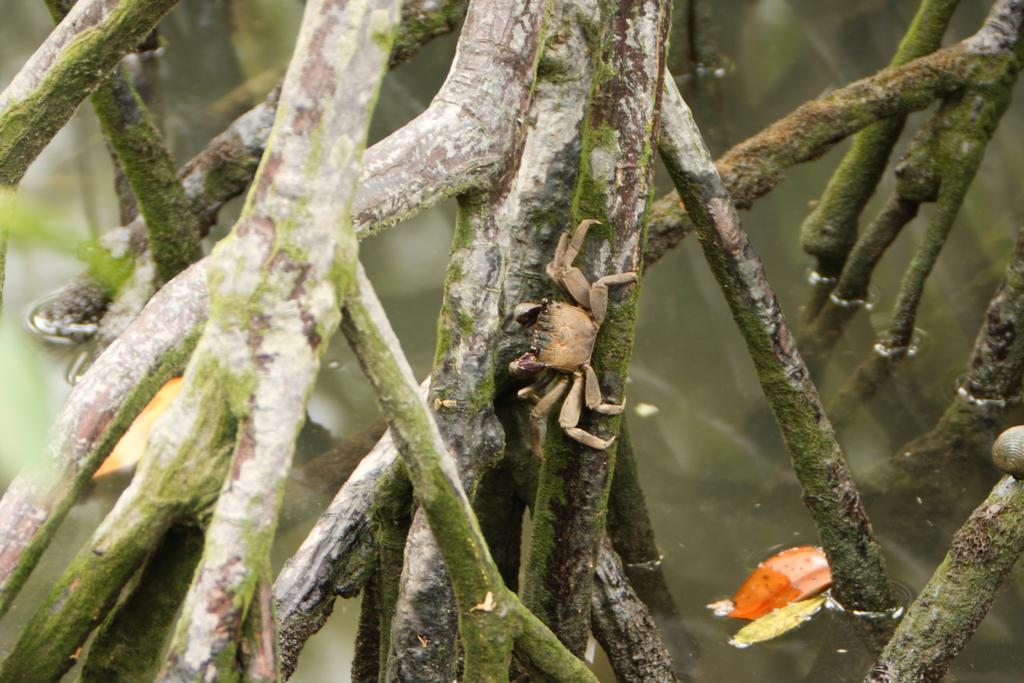What type of animal is on the branch of a tree in the image? There is a crab on the branch of a tree in the image. Can you describe the background of the image? There are other objects visible in the background of the image. How many friends does the crab have in the image? There is no indication in the image of the crab having any friends. 